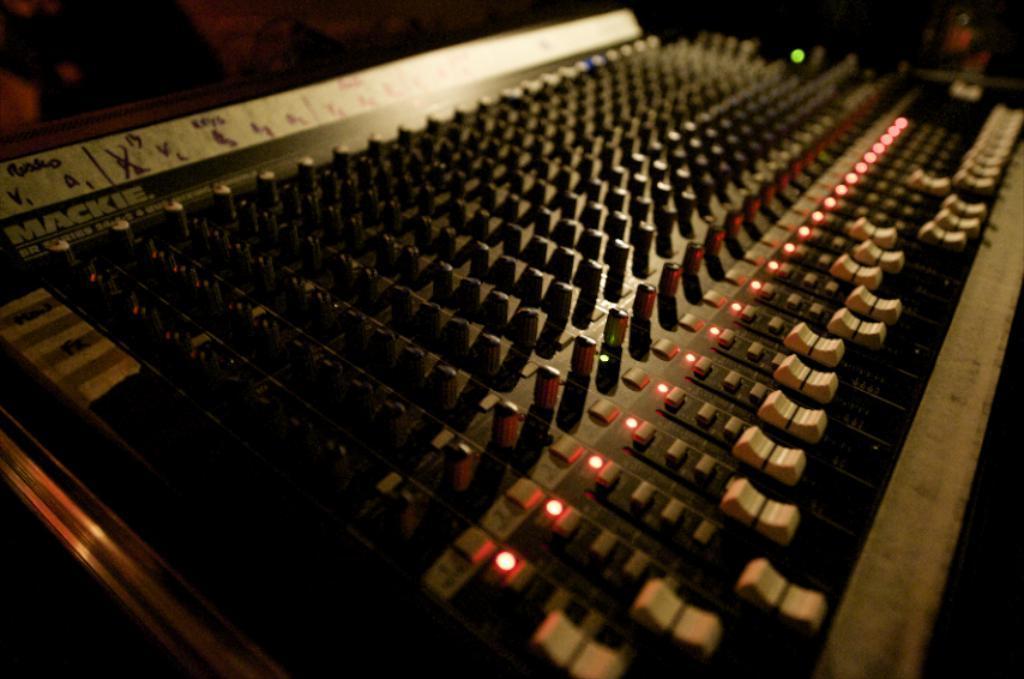Can you describe this image briefly? In this image we can see a musical instrument and a dark background. 